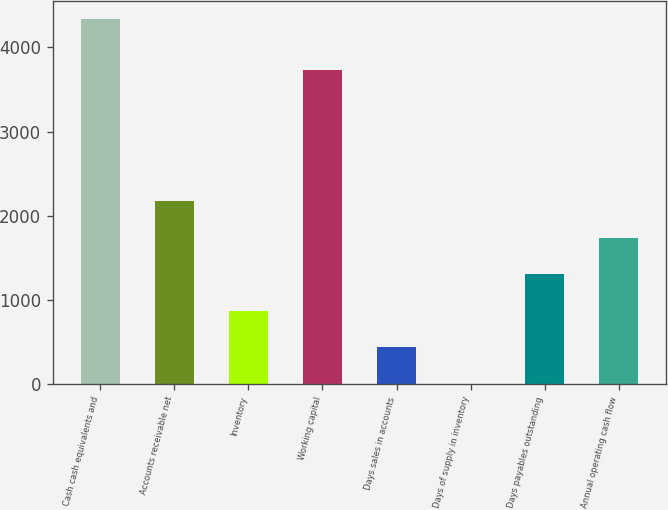Convert chart. <chart><loc_0><loc_0><loc_500><loc_500><bar_chart><fcel>Cash cash equivalents and<fcel>Accounts receivable net<fcel>Inventory<fcel>Working capital<fcel>Days sales in accounts<fcel>Days of supply in inventory<fcel>Days payables outstanding<fcel>Annual operating cash flow<nl><fcel>4337<fcel>2170.5<fcel>870.6<fcel>3730<fcel>437.3<fcel>4<fcel>1303.9<fcel>1737.2<nl></chart> 